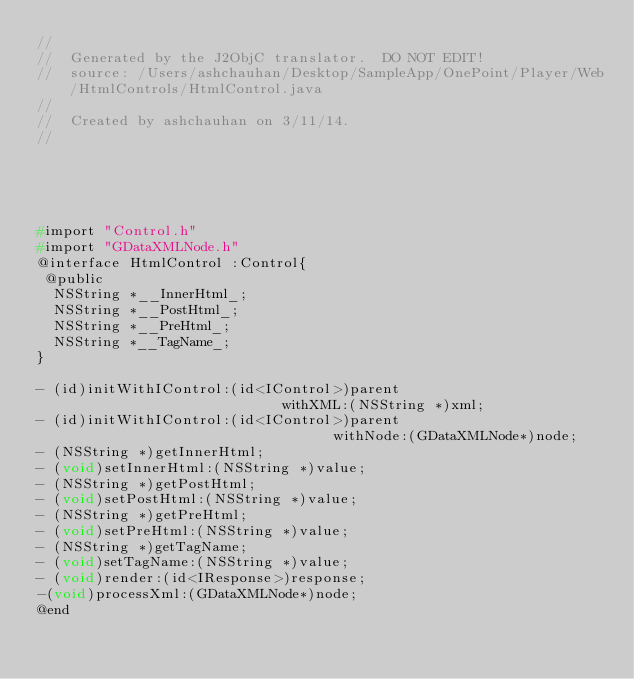<code> <loc_0><loc_0><loc_500><loc_500><_C_>//
//  Generated by the J2ObjC translator.  DO NOT EDIT!
//  source: /Users/ashchauhan/Desktop/SampleApp/OnePoint/Player/Web/HtmlControls/HtmlControl.java
//
//  Created by ashchauhan on 3/11/14.
//





#import "Control.h"
#import "GDataXMLNode.h"
@interface HtmlControl :Control{
 @public
  NSString *__InnerHtml_;
  NSString *__PostHtml_;
  NSString *__PreHtml_;
  NSString *__TagName_;
}

- (id)initWithIControl:(id<IControl>)parent
                             withXML:(NSString *)xml;
- (id)initWithIControl:(id<IControl>)parent
                                   withNode:(GDataXMLNode*)node;
- (NSString *)getInnerHtml;
- (void)setInnerHtml:(NSString *)value;
- (NSString *)getPostHtml;
- (void)setPostHtml:(NSString *)value;
- (NSString *)getPreHtml;
- (void)setPreHtml:(NSString *)value;
- (NSString *)getTagName;
- (void)setTagName:(NSString *)value;
- (void)render:(id<IResponse>)response;
-(void)processXml:(GDataXMLNode*)node;
@end


</code> 